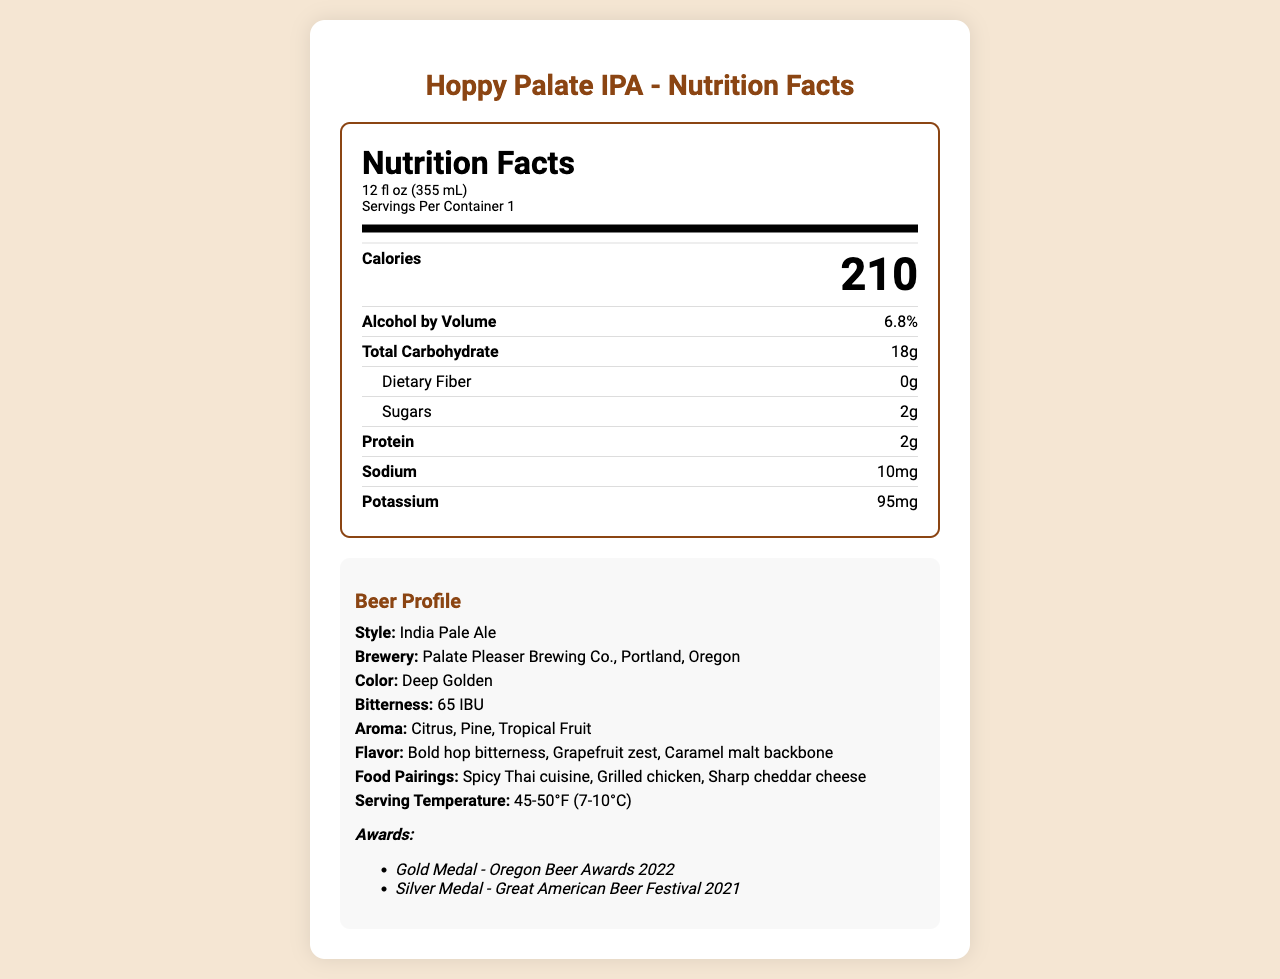What is the calorie content per serving? The document states that each serving, which is 12 fl oz, contains 210 calories.
Answer: 210 calories What is the alcohol by volume (ABV) percentage? The alcohol by volume is explicitly listed as 6.8%.
Answer: 6.8% How much total carbohydrate does each serving contain? The total carbohydrate content per serving is 18 grams as mentioned in the document.
Answer: 18g What is the brewery name and its location? The brewery name is Palate Pleaser Brewing Co., and it is located in Portland, Oregon.
Answer: Palate Pleaser Brewing Co., Portland, Oregon Which food pairings are suggested for the "Hoppy Palate IPA"? The document suggests pairing the beer with Spicy Thai cuisine, Grilled chicken, and Sharp cheddar cheese.
Answer: Spicy Thai cuisine, Grilled chicken, Sharp cheddar cheese What aroma notes are mentioned for this beer? The aroma notes mentioned in the document are Citrus, Pine, and Tropical Fruit.
Answer: Citrus, Pine, Tropical Fruit How many grams of protein are there per serving? The document states that there are 2 grams of protein per serving.
Answer: 2g What is the bitterness unit (IBU) of this beer? The bitterness unit for the Hoppy Palate IPA is listed as 65 IBU.
Answer: 65 IBU How much sodium does the beer contain per serving? Each serving contains 10 mg of sodium as specified in the document.
Answer: 10mg What is the serving temperature for the Hoppy Palate IPA? The recommended serving temperature is 45-50°F (7-10°C).
Answer: 45-50°F (7-10°C) What awards has the Hoppy Palate IPA won? The awards listed are Gold Medal - Oregon Beer Awards 2022 and Silver Medal - Great American Beer Festival 2021.
Answer: Gold Medal - Oregon Beer Awards 2022, Silver Medal - Great American Beer Festival 2021 Choose the correct brewery for "Hoppy Palate IPA":
A. Hoppy Brewery Co.
B. Palate Pleaser Brewing Co.
C. Craft Brew Collective
D. Oregon Ale Works The correct brewery is Palate Pleaser Brewing Co.
Answer: B What is the color of "Hoppy Palate IPA"? 
1. Amber
2. Deep Golden
3. Pale Yellow
4. Dark Brown The color of the beer is specified as Deep Golden.
Answer: 2 Does this beer contain any dietary fiber? The document states that the dietary fiber content is 0 grams.
Answer: No What is the total fat content in each serving? The total fat content isn't listed in the provided document; only specific subcategories of fat are mentioned as 0g.
Answer: Not enough information What ingredients are used to make Hoppy Palate IPA? The document lists the ingredients as Water, Malted Barley, Hops, and Yeast.
Answer: Water, Malted Barley, Hops, Yeast 